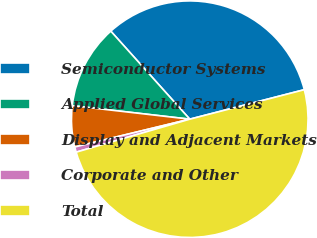Convert chart. <chart><loc_0><loc_0><loc_500><loc_500><pie_chart><fcel>Semiconductor Systems<fcel>Applied Global Services<fcel>Display and Adjacent Markets<fcel>Corporate and Other<fcel>Total<nl><fcel>32.63%<fcel>11.54%<fcel>5.6%<fcel>0.72%<fcel>49.51%<nl></chart> 